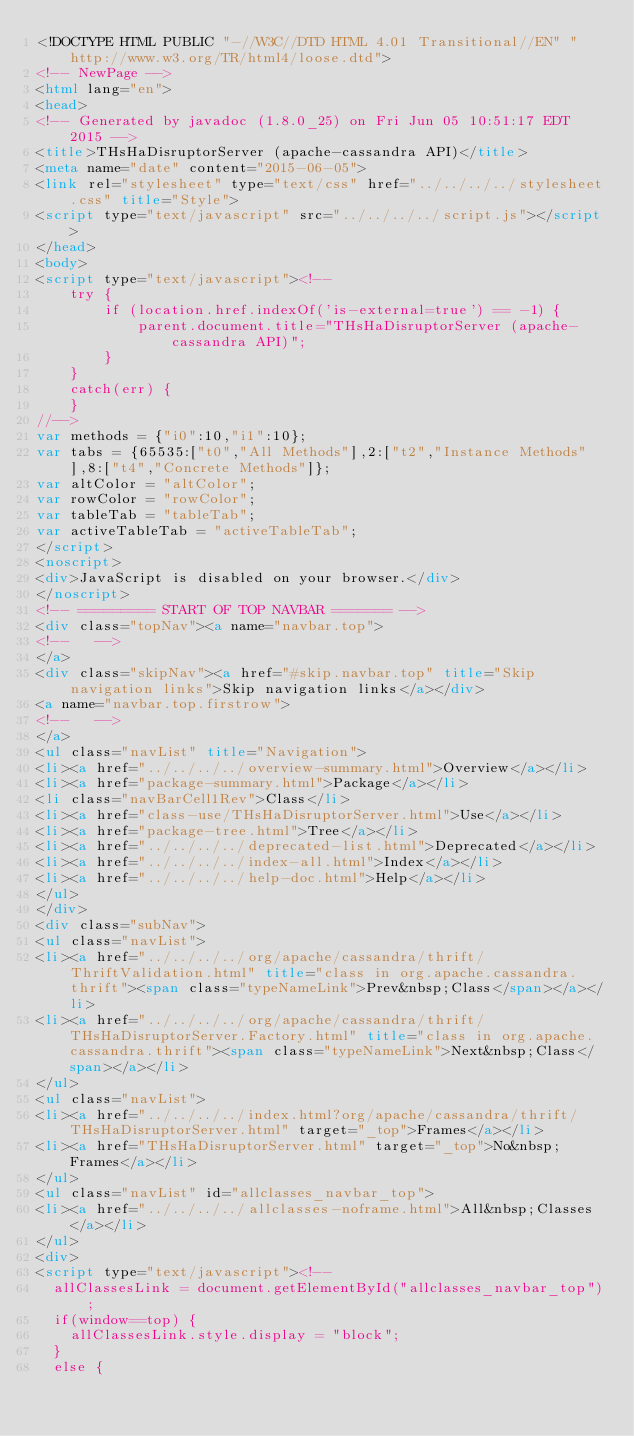Convert code to text. <code><loc_0><loc_0><loc_500><loc_500><_HTML_><!DOCTYPE HTML PUBLIC "-//W3C//DTD HTML 4.01 Transitional//EN" "http://www.w3.org/TR/html4/loose.dtd">
<!-- NewPage -->
<html lang="en">
<head>
<!-- Generated by javadoc (1.8.0_25) on Fri Jun 05 10:51:17 EDT 2015 -->
<title>THsHaDisruptorServer (apache-cassandra API)</title>
<meta name="date" content="2015-06-05">
<link rel="stylesheet" type="text/css" href="../../../../stylesheet.css" title="Style">
<script type="text/javascript" src="../../../../script.js"></script>
</head>
<body>
<script type="text/javascript"><!--
    try {
        if (location.href.indexOf('is-external=true') == -1) {
            parent.document.title="THsHaDisruptorServer (apache-cassandra API)";
        }
    }
    catch(err) {
    }
//-->
var methods = {"i0":10,"i1":10};
var tabs = {65535:["t0","All Methods"],2:["t2","Instance Methods"],8:["t4","Concrete Methods"]};
var altColor = "altColor";
var rowColor = "rowColor";
var tableTab = "tableTab";
var activeTableTab = "activeTableTab";
</script>
<noscript>
<div>JavaScript is disabled on your browser.</div>
</noscript>
<!-- ========= START OF TOP NAVBAR ======= -->
<div class="topNav"><a name="navbar.top">
<!--   -->
</a>
<div class="skipNav"><a href="#skip.navbar.top" title="Skip navigation links">Skip navigation links</a></div>
<a name="navbar.top.firstrow">
<!--   -->
</a>
<ul class="navList" title="Navigation">
<li><a href="../../../../overview-summary.html">Overview</a></li>
<li><a href="package-summary.html">Package</a></li>
<li class="navBarCell1Rev">Class</li>
<li><a href="class-use/THsHaDisruptorServer.html">Use</a></li>
<li><a href="package-tree.html">Tree</a></li>
<li><a href="../../../../deprecated-list.html">Deprecated</a></li>
<li><a href="../../../../index-all.html">Index</a></li>
<li><a href="../../../../help-doc.html">Help</a></li>
</ul>
</div>
<div class="subNav">
<ul class="navList">
<li><a href="../../../../org/apache/cassandra/thrift/ThriftValidation.html" title="class in org.apache.cassandra.thrift"><span class="typeNameLink">Prev&nbsp;Class</span></a></li>
<li><a href="../../../../org/apache/cassandra/thrift/THsHaDisruptorServer.Factory.html" title="class in org.apache.cassandra.thrift"><span class="typeNameLink">Next&nbsp;Class</span></a></li>
</ul>
<ul class="navList">
<li><a href="../../../../index.html?org/apache/cassandra/thrift/THsHaDisruptorServer.html" target="_top">Frames</a></li>
<li><a href="THsHaDisruptorServer.html" target="_top">No&nbsp;Frames</a></li>
</ul>
<ul class="navList" id="allclasses_navbar_top">
<li><a href="../../../../allclasses-noframe.html">All&nbsp;Classes</a></li>
</ul>
<div>
<script type="text/javascript"><!--
  allClassesLink = document.getElementById("allclasses_navbar_top");
  if(window==top) {
    allClassesLink.style.display = "block";
  }
  else {</code> 